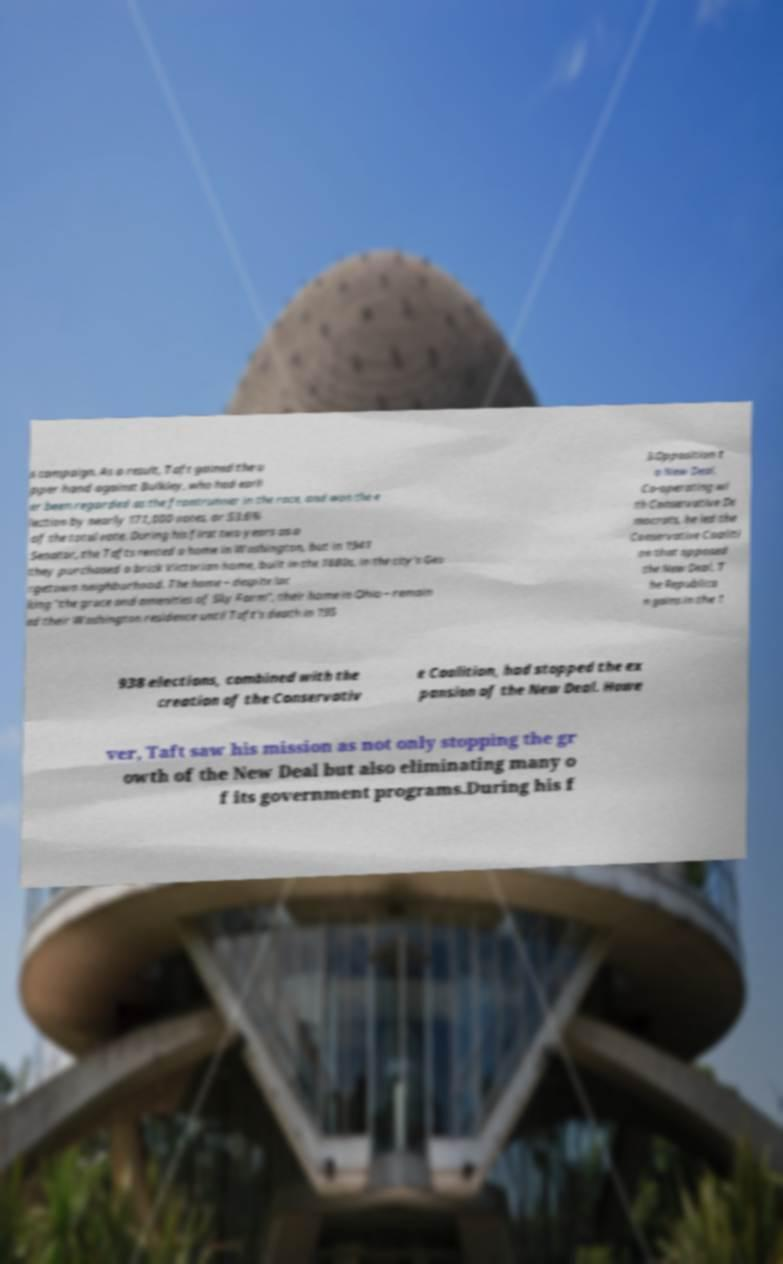Can you accurately transcribe the text from the provided image for me? s campaign. As a result, Taft gained the u pper hand against Bulkley, who had earli er been regarded as the frontrunner in the race, and won the e lection by nearly 171,000 votes, or 53.6% of the total vote. During his first two years as a Senator, the Tafts rented a home in Washington, but in 1941 they purchased a brick Victorian home, built in the 1880s, in the city's Geo rgetown neighborhood. The home – despite lac king "the grace and amenities of Sky Farm", their home in Ohio – remain ed their Washington residence until Taft's death in 195 3.Opposition t o New Deal. Co-operating wi th Conservative De mocrats, he led the Conservative Coaliti on that opposed the New Deal. T he Republica n gains in the 1 938 elections, combined with the creation of the Conservativ e Coalition, had stopped the ex pansion of the New Deal. Howe ver, Taft saw his mission as not only stopping the gr owth of the New Deal but also eliminating many o f its government programs.During his f 